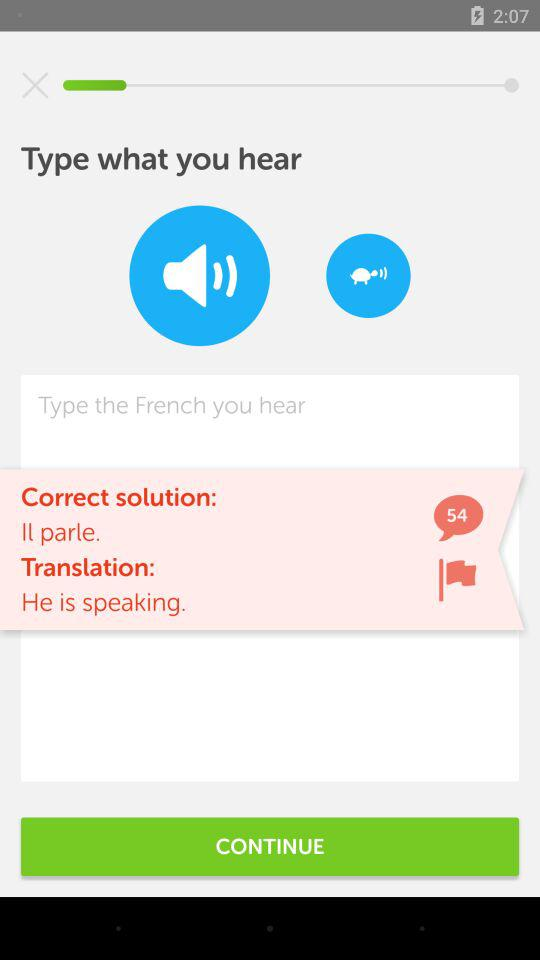How many comments are there for the correct solution? There are 54 comments. 